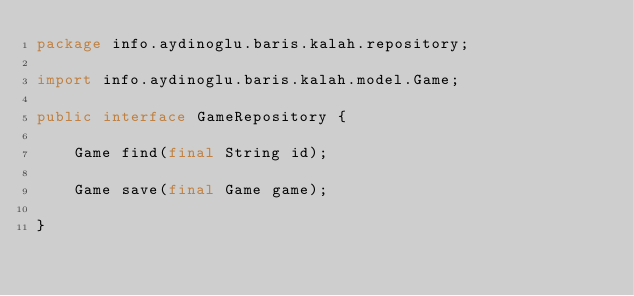<code> <loc_0><loc_0><loc_500><loc_500><_Java_>package info.aydinoglu.baris.kalah.repository;

import info.aydinoglu.baris.kalah.model.Game;

public interface GameRepository {

    Game find(final String id);

    Game save(final Game game);

}
</code> 